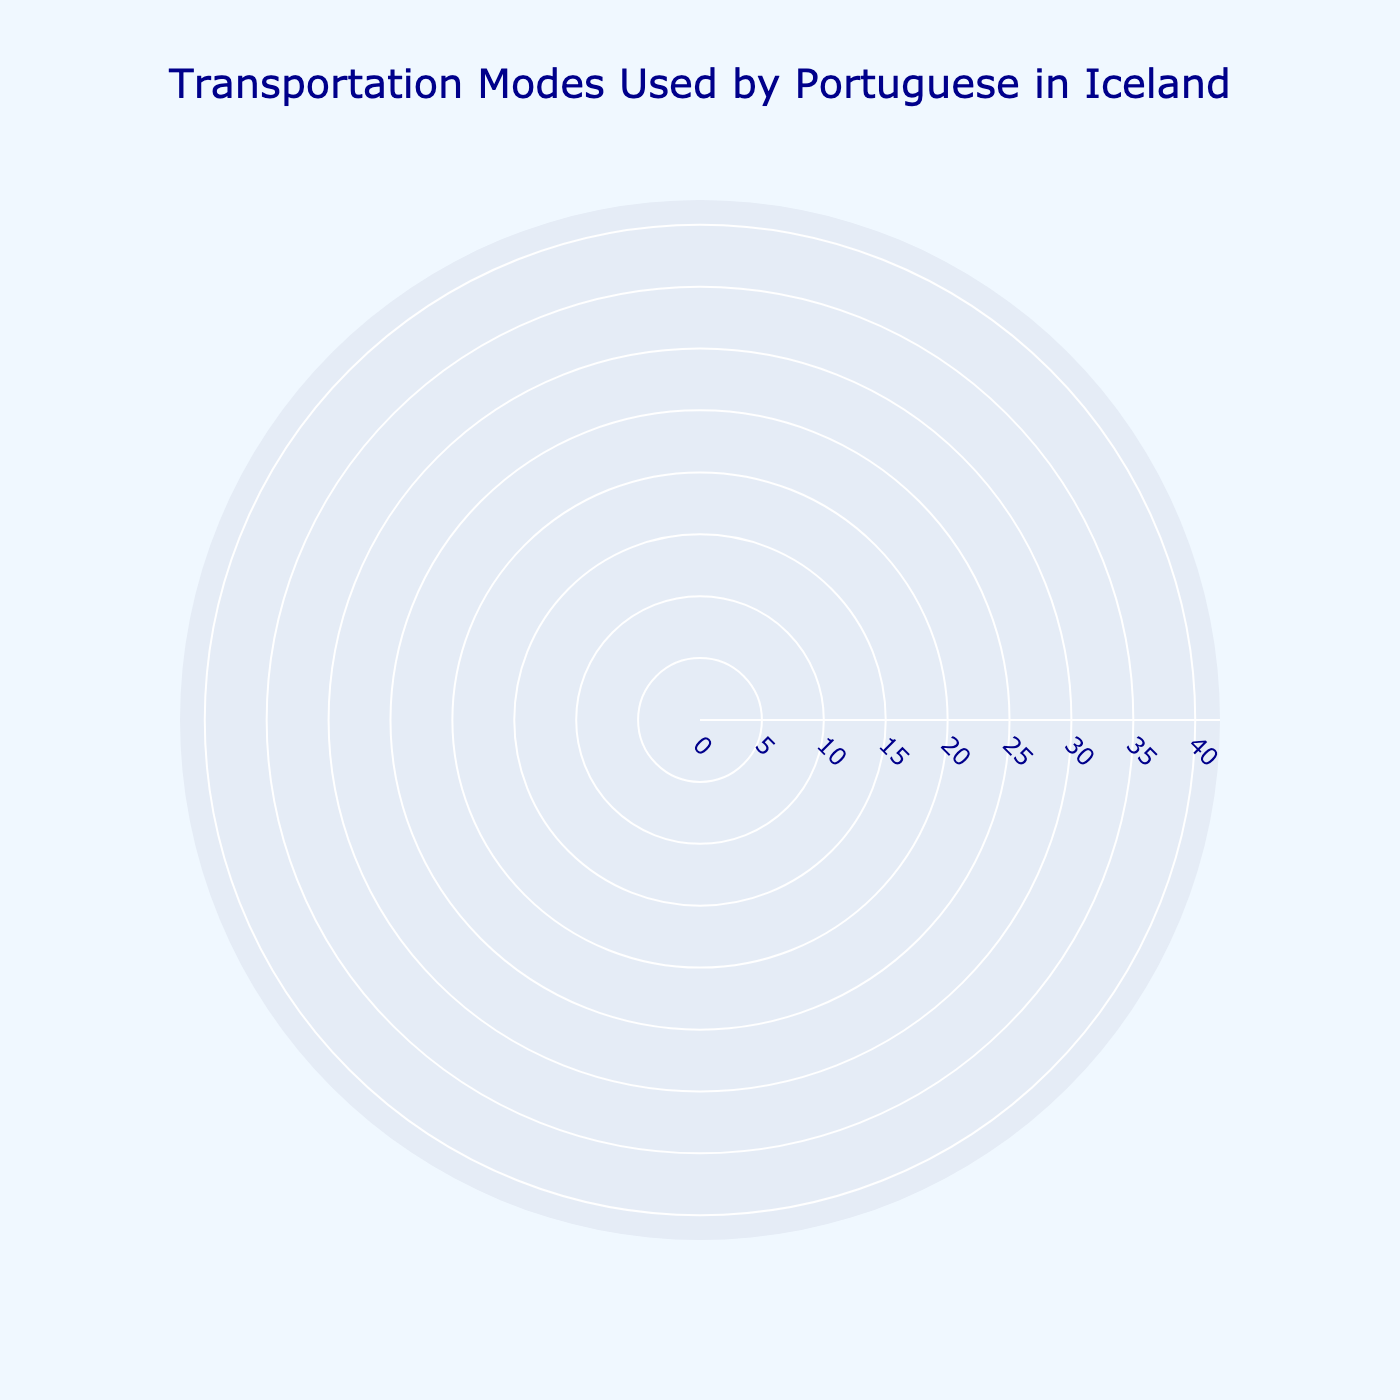How many different modes of transportation are represented in the chart? Count the number of different segments on the rose chart.
Answer: 8 What is the most popular mode of transportation among Portuguese people living in Iceland according to the chart? Observe the segment with the largest radius.
Answer: Personal Car Which transportation modes have usage percentages less than 10%? Look for segments whose radii are shorter than the 10% mark on the radial axis.
Answer: Walking, Carpooling, Taxi/Rideshare, Motorbike/Scooter, Electric Scooter Which modes of transportation have usage percentages equal to or greater than 15%? Identify segments with radii that start at or above the 15% mark.
Answer: Personal Car, Public Bus, Bicycle How much more popular is using a personal car compared to walking? Subtract the usage percentage of walking from that of personal cars. Calculation: 35% - 10% = 25%
Answer: 25% What are the combined usage percentages of the three least popular transportation modes? Add the usage percentages of Motorbike/Scooter, Electric Scooter, and Taxi/Rideshare. Calculation: 3% + 2% + 7% = 12%
Answer: 12% Which mode of transportation has the smallest usage percentage? Look for the segment with the shortest radius.
Answer: Electric Scooter What is the total percentage of usage for non-car-based transportation modes (excluding Personal Car and Carpooling)? Sum the usage percentages of all modes excluding Personal Car and Carpooling. Calculation: 20% (Public Bus) + 15% (Bicycle) + 10% (Walking) + 7% (Taxi/Rideshare) + 3% (Motorbike/Scooter) + 2% (Electric Scooter) = 57%
Answer: 57% How much more popular is using public transportation (Public Bus) compared to carpooling? Subtract the usage percentage of carpooling from that of public buses. Calculation: 20% - 8% = 12%
Answer: 12% Which transportation modes have an identical marker color in the chart? Since marker colors typically follow a gradient scale and are unique for each mode, there are no transportation modes with identical marker colors in this chart.
Answer: None 